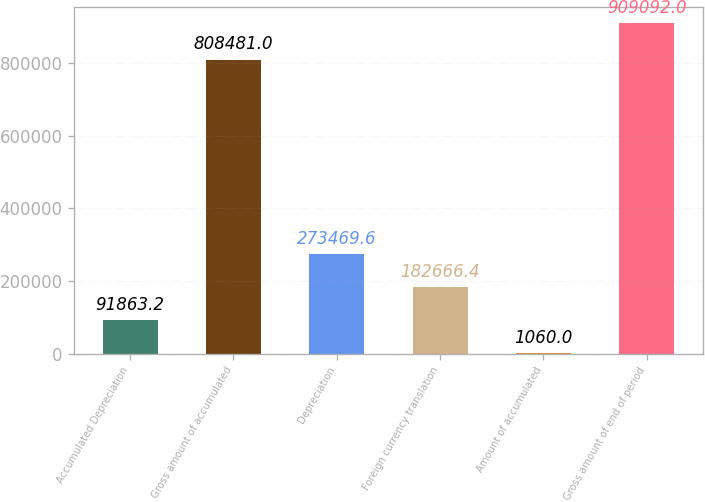Convert chart. <chart><loc_0><loc_0><loc_500><loc_500><bar_chart><fcel>Accumulated Depreciation<fcel>Gross amount of accumulated<fcel>Depreciation<fcel>Foreign currency translation<fcel>Amount of accumulated<fcel>Gross amount of end of period<nl><fcel>91863.2<fcel>808481<fcel>273470<fcel>182666<fcel>1060<fcel>909092<nl></chart> 